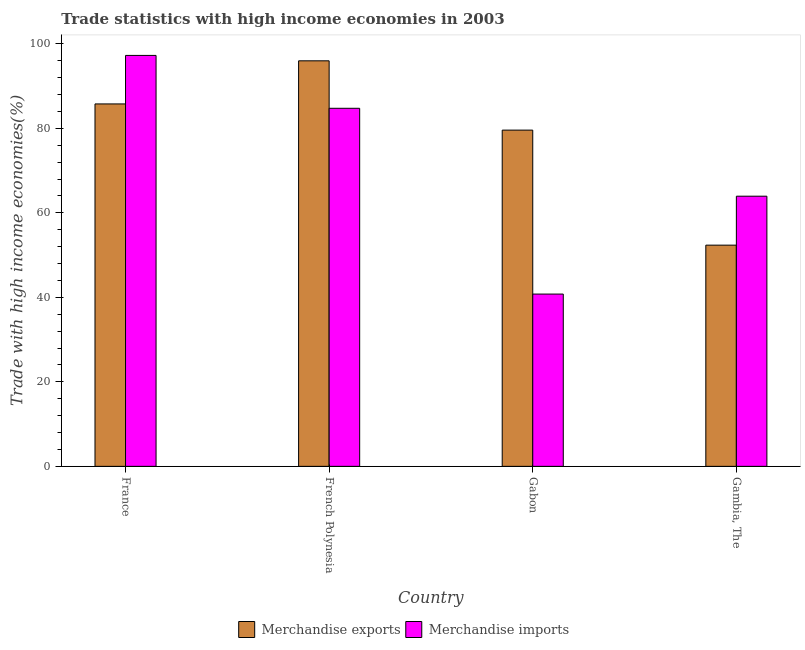Are the number of bars per tick equal to the number of legend labels?
Provide a succinct answer. Yes. What is the label of the 2nd group of bars from the left?
Offer a very short reply. French Polynesia. What is the merchandise imports in French Polynesia?
Offer a terse response. 84.74. Across all countries, what is the maximum merchandise exports?
Provide a short and direct response. 95.98. Across all countries, what is the minimum merchandise exports?
Offer a terse response. 52.35. In which country was the merchandise exports minimum?
Provide a succinct answer. Gambia, The. What is the total merchandise exports in the graph?
Ensure brevity in your answer.  313.67. What is the difference between the merchandise exports in French Polynesia and that in Gabon?
Your answer should be compact. 16.4. What is the difference between the merchandise exports in French Polynesia and the merchandise imports in Gabon?
Your answer should be very brief. 55.2. What is the average merchandise exports per country?
Provide a succinct answer. 78.42. What is the difference between the merchandise imports and merchandise exports in Gambia, The?
Make the answer very short. 11.58. In how many countries, is the merchandise imports greater than 72 %?
Offer a terse response. 2. What is the ratio of the merchandise exports in France to that in French Polynesia?
Your response must be concise. 0.89. Is the difference between the merchandise imports in French Polynesia and Gambia, The greater than the difference between the merchandise exports in French Polynesia and Gambia, The?
Offer a terse response. No. What is the difference between the highest and the second highest merchandise imports?
Make the answer very short. 12.51. What is the difference between the highest and the lowest merchandise exports?
Provide a succinct answer. 43.62. In how many countries, is the merchandise imports greater than the average merchandise imports taken over all countries?
Give a very brief answer. 2. Is the sum of the merchandise exports in France and Gabon greater than the maximum merchandise imports across all countries?
Provide a short and direct response. Yes. What does the 2nd bar from the right in Gabon represents?
Your answer should be very brief. Merchandise exports. Are all the bars in the graph horizontal?
Provide a succinct answer. No. How many countries are there in the graph?
Your answer should be very brief. 4. Are the values on the major ticks of Y-axis written in scientific E-notation?
Give a very brief answer. No. Does the graph contain any zero values?
Offer a very short reply. No. How many legend labels are there?
Keep it short and to the point. 2. What is the title of the graph?
Ensure brevity in your answer.  Trade statistics with high income economies in 2003. Does "Male labor force" appear as one of the legend labels in the graph?
Your answer should be very brief. No. What is the label or title of the Y-axis?
Your answer should be compact. Trade with high income economies(%). What is the Trade with high income economies(%) of Merchandise exports in France?
Your answer should be compact. 85.77. What is the Trade with high income economies(%) of Merchandise imports in France?
Offer a very short reply. 97.25. What is the Trade with high income economies(%) in Merchandise exports in French Polynesia?
Make the answer very short. 95.98. What is the Trade with high income economies(%) of Merchandise imports in French Polynesia?
Keep it short and to the point. 84.74. What is the Trade with high income economies(%) in Merchandise exports in Gabon?
Ensure brevity in your answer.  79.57. What is the Trade with high income economies(%) of Merchandise imports in Gabon?
Offer a terse response. 40.77. What is the Trade with high income economies(%) in Merchandise exports in Gambia, The?
Give a very brief answer. 52.35. What is the Trade with high income economies(%) of Merchandise imports in Gambia, The?
Give a very brief answer. 63.94. Across all countries, what is the maximum Trade with high income economies(%) of Merchandise exports?
Offer a very short reply. 95.98. Across all countries, what is the maximum Trade with high income economies(%) of Merchandise imports?
Keep it short and to the point. 97.25. Across all countries, what is the minimum Trade with high income economies(%) in Merchandise exports?
Keep it short and to the point. 52.35. Across all countries, what is the minimum Trade with high income economies(%) of Merchandise imports?
Provide a short and direct response. 40.77. What is the total Trade with high income economies(%) in Merchandise exports in the graph?
Your answer should be compact. 313.67. What is the total Trade with high income economies(%) of Merchandise imports in the graph?
Offer a terse response. 286.7. What is the difference between the Trade with high income economies(%) in Merchandise exports in France and that in French Polynesia?
Your response must be concise. -10.2. What is the difference between the Trade with high income economies(%) in Merchandise imports in France and that in French Polynesia?
Your answer should be very brief. 12.51. What is the difference between the Trade with high income economies(%) in Merchandise exports in France and that in Gabon?
Provide a short and direct response. 6.2. What is the difference between the Trade with high income economies(%) in Merchandise imports in France and that in Gabon?
Your answer should be compact. 56.48. What is the difference between the Trade with high income economies(%) in Merchandise exports in France and that in Gambia, The?
Your answer should be very brief. 33.42. What is the difference between the Trade with high income economies(%) in Merchandise imports in France and that in Gambia, The?
Give a very brief answer. 33.32. What is the difference between the Trade with high income economies(%) in Merchandise exports in French Polynesia and that in Gabon?
Your answer should be compact. 16.4. What is the difference between the Trade with high income economies(%) in Merchandise imports in French Polynesia and that in Gabon?
Offer a very short reply. 43.97. What is the difference between the Trade with high income economies(%) in Merchandise exports in French Polynesia and that in Gambia, The?
Provide a short and direct response. 43.62. What is the difference between the Trade with high income economies(%) in Merchandise imports in French Polynesia and that in Gambia, The?
Your answer should be compact. 20.8. What is the difference between the Trade with high income economies(%) in Merchandise exports in Gabon and that in Gambia, The?
Ensure brevity in your answer.  27.22. What is the difference between the Trade with high income economies(%) in Merchandise imports in Gabon and that in Gambia, The?
Provide a short and direct response. -23.16. What is the difference between the Trade with high income economies(%) in Merchandise exports in France and the Trade with high income economies(%) in Merchandise imports in French Polynesia?
Ensure brevity in your answer.  1.03. What is the difference between the Trade with high income economies(%) of Merchandise exports in France and the Trade with high income economies(%) of Merchandise imports in Gabon?
Ensure brevity in your answer.  45. What is the difference between the Trade with high income economies(%) of Merchandise exports in France and the Trade with high income economies(%) of Merchandise imports in Gambia, The?
Offer a very short reply. 21.84. What is the difference between the Trade with high income economies(%) in Merchandise exports in French Polynesia and the Trade with high income economies(%) in Merchandise imports in Gabon?
Keep it short and to the point. 55.2. What is the difference between the Trade with high income economies(%) in Merchandise exports in French Polynesia and the Trade with high income economies(%) in Merchandise imports in Gambia, The?
Provide a short and direct response. 32.04. What is the difference between the Trade with high income economies(%) of Merchandise exports in Gabon and the Trade with high income economies(%) of Merchandise imports in Gambia, The?
Your response must be concise. 15.64. What is the average Trade with high income economies(%) of Merchandise exports per country?
Keep it short and to the point. 78.42. What is the average Trade with high income economies(%) in Merchandise imports per country?
Your answer should be very brief. 71.67. What is the difference between the Trade with high income economies(%) in Merchandise exports and Trade with high income economies(%) in Merchandise imports in France?
Your answer should be compact. -11.48. What is the difference between the Trade with high income economies(%) of Merchandise exports and Trade with high income economies(%) of Merchandise imports in French Polynesia?
Your answer should be compact. 11.24. What is the difference between the Trade with high income economies(%) of Merchandise exports and Trade with high income economies(%) of Merchandise imports in Gabon?
Offer a very short reply. 38.8. What is the difference between the Trade with high income economies(%) of Merchandise exports and Trade with high income economies(%) of Merchandise imports in Gambia, The?
Give a very brief answer. -11.58. What is the ratio of the Trade with high income economies(%) in Merchandise exports in France to that in French Polynesia?
Your response must be concise. 0.89. What is the ratio of the Trade with high income economies(%) in Merchandise imports in France to that in French Polynesia?
Keep it short and to the point. 1.15. What is the ratio of the Trade with high income economies(%) in Merchandise exports in France to that in Gabon?
Ensure brevity in your answer.  1.08. What is the ratio of the Trade with high income economies(%) in Merchandise imports in France to that in Gabon?
Make the answer very short. 2.39. What is the ratio of the Trade with high income economies(%) in Merchandise exports in France to that in Gambia, The?
Provide a short and direct response. 1.64. What is the ratio of the Trade with high income economies(%) of Merchandise imports in France to that in Gambia, The?
Give a very brief answer. 1.52. What is the ratio of the Trade with high income economies(%) of Merchandise exports in French Polynesia to that in Gabon?
Keep it short and to the point. 1.21. What is the ratio of the Trade with high income economies(%) in Merchandise imports in French Polynesia to that in Gabon?
Make the answer very short. 2.08. What is the ratio of the Trade with high income economies(%) in Merchandise exports in French Polynesia to that in Gambia, The?
Ensure brevity in your answer.  1.83. What is the ratio of the Trade with high income economies(%) in Merchandise imports in French Polynesia to that in Gambia, The?
Provide a short and direct response. 1.33. What is the ratio of the Trade with high income economies(%) in Merchandise exports in Gabon to that in Gambia, The?
Offer a very short reply. 1.52. What is the ratio of the Trade with high income economies(%) in Merchandise imports in Gabon to that in Gambia, The?
Offer a terse response. 0.64. What is the difference between the highest and the second highest Trade with high income economies(%) of Merchandise exports?
Make the answer very short. 10.2. What is the difference between the highest and the second highest Trade with high income economies(%) in Merchandise imports?
Your response must be concise. 12.51. What is the difference between the highest and the lowest Trade with high income economies(%) in Merchandise exports?
Make the answer very short. 43.62. What is the difference between the highest and the lowest Trade with high income economies(%) in Merchandise imports?
Provide a succinct answer. 56.48. 